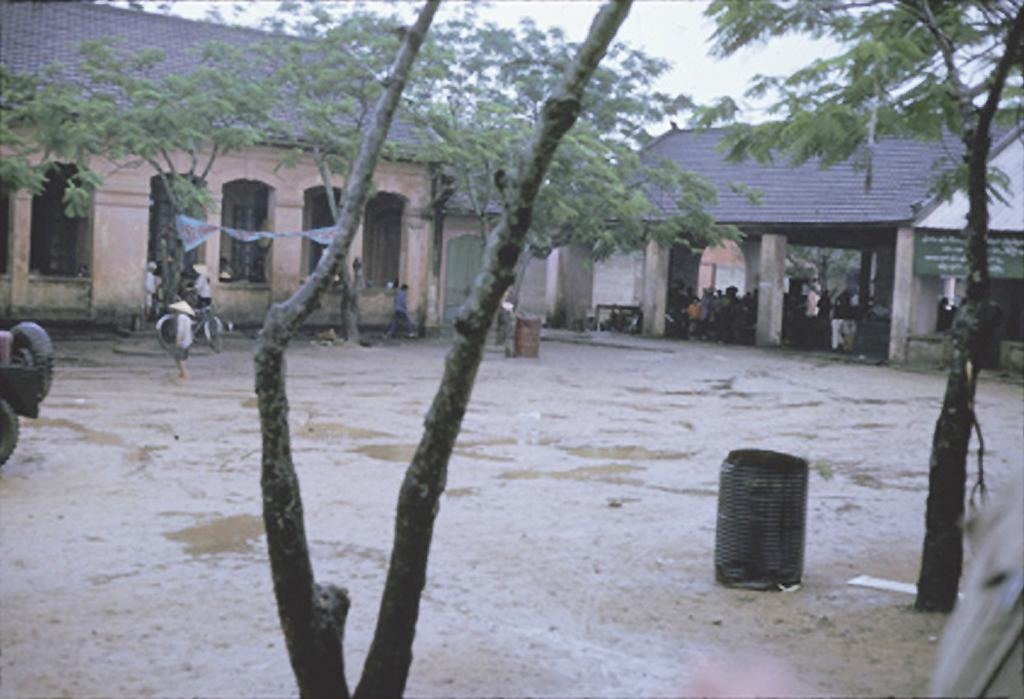What type of structures can be seen in the image? There are houses in the image. What object is present for waste disposal? There is a dustbin in the image. Who or what is present in the image besides the houses and dustbin? There are people and a bicycle in the image. What type of vegetation is visible in the image? There are trees in the image. What part of the natural environment is visible in the image? The sky is visible in the image. What unit is being used to measure the height of the grandfather in the image? There is no grandfather or measurement unit present in the image. What type of wall is visible in the image? There is no wall visible in the image. 